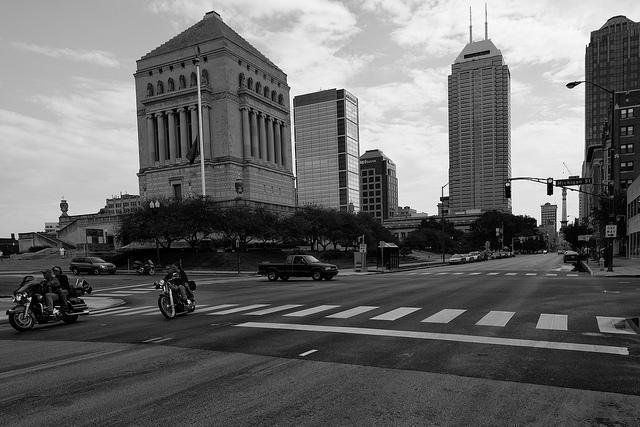What did the motorcycle near the crosswalk just do?
Answer the question by selecting the correct answer among the 4 following choices and explain your choice with a short sentence. The answer should be formatted with the following format: `Answer: choice
Rationale: rationale.`
Options: Turn, fall, break, crash. Answer: turn.
Rationale: The motorcycle is turning. 